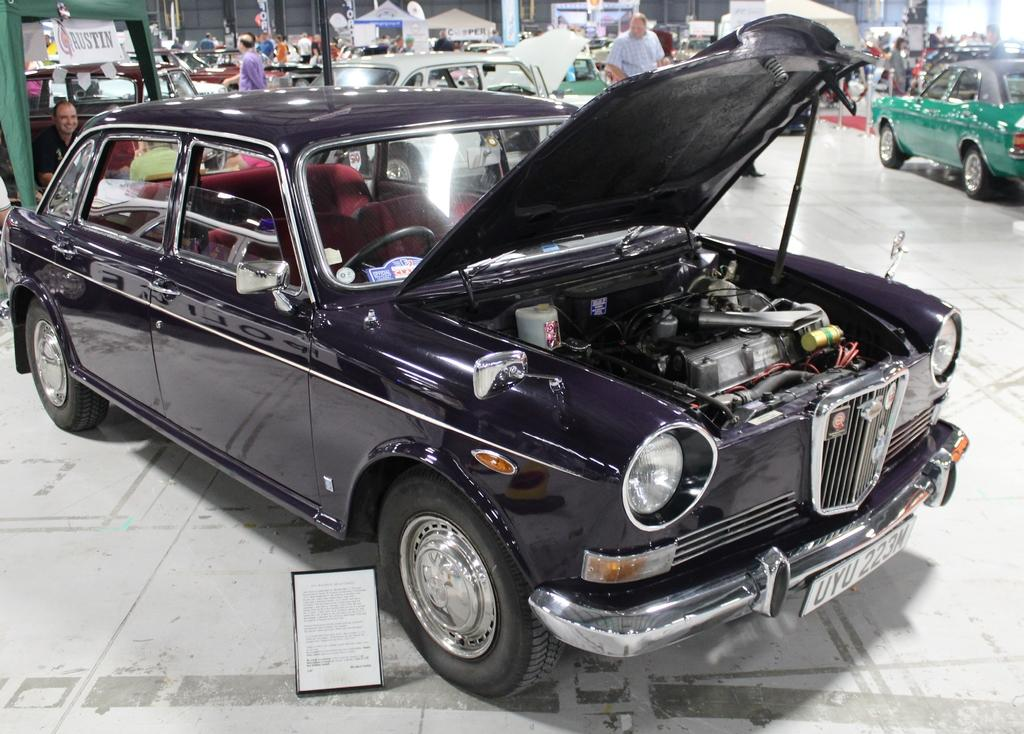What can be seen in the image related to vehicles? There are different types of cars in the image, including various car models. Are there any people present in the image? Yes, there are people in the background of the image. What might the people be doing in the image? The people are likely visiting a garage and are interested in the cars. Can you see a lake in the background of the image? No, there is no lake present in the image. 